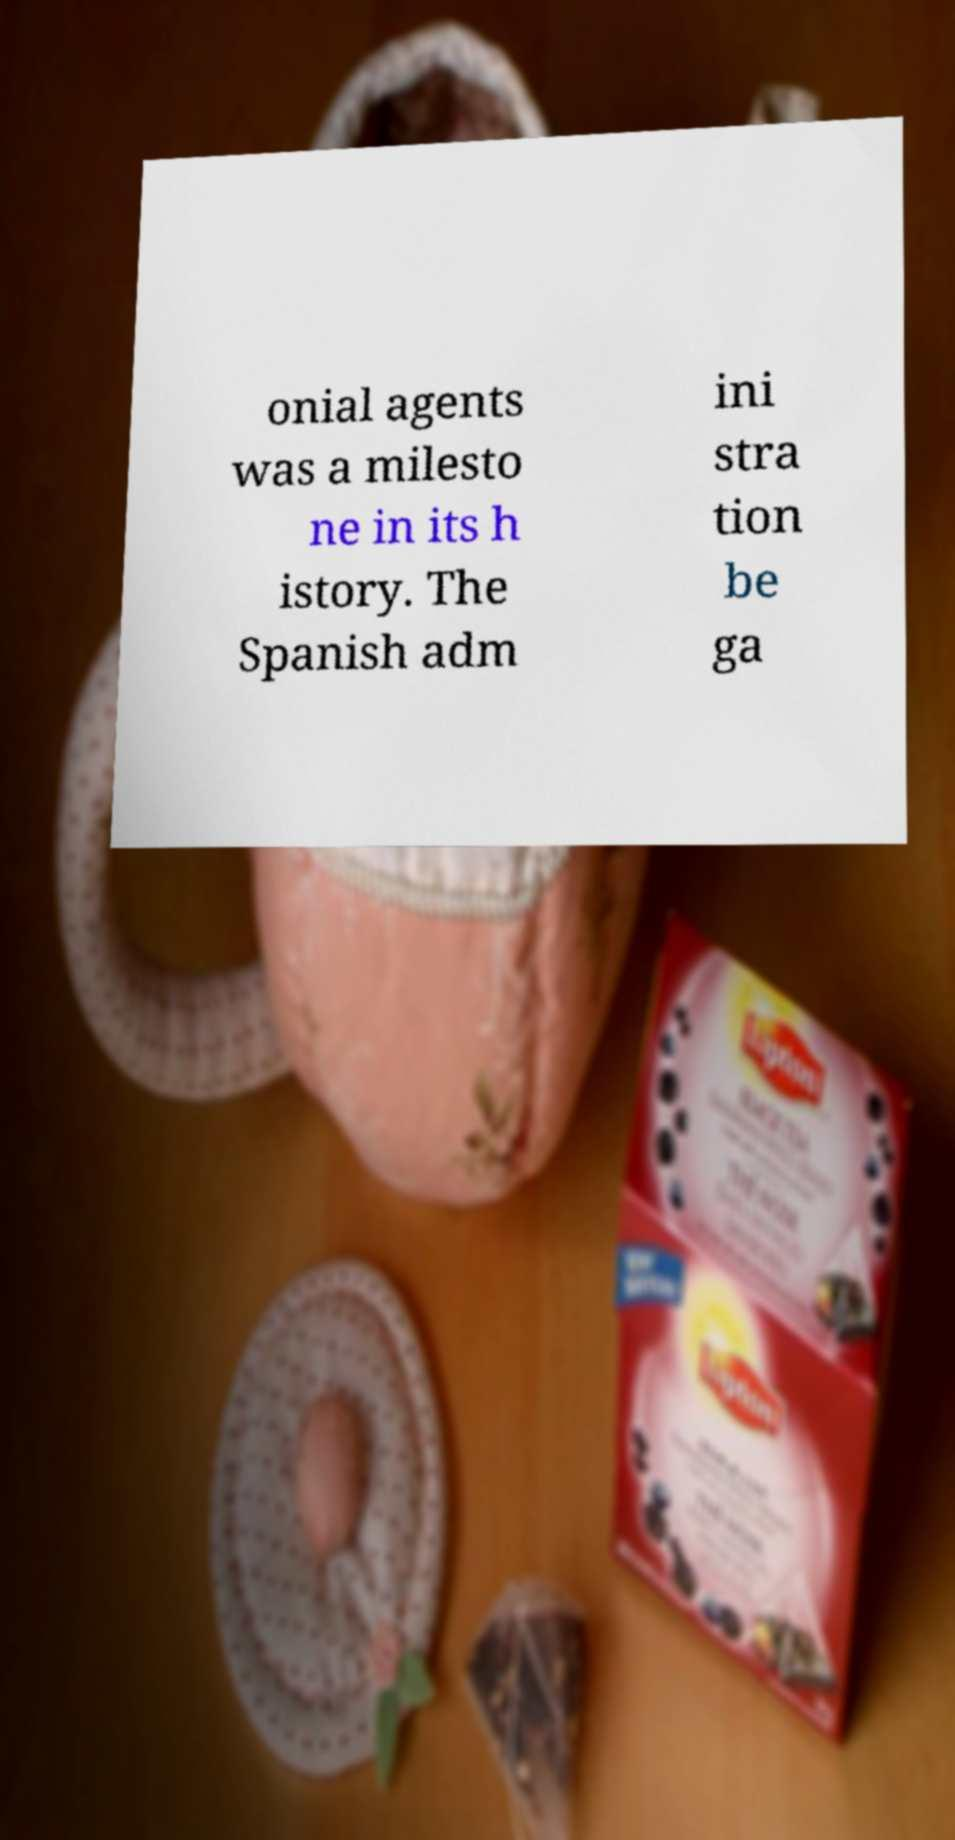Could you assist in decoding the text presented in this image and type it out clearly? onial agents was a milesto ne in its h istory. The Spanish adm ini stra tion be ga 